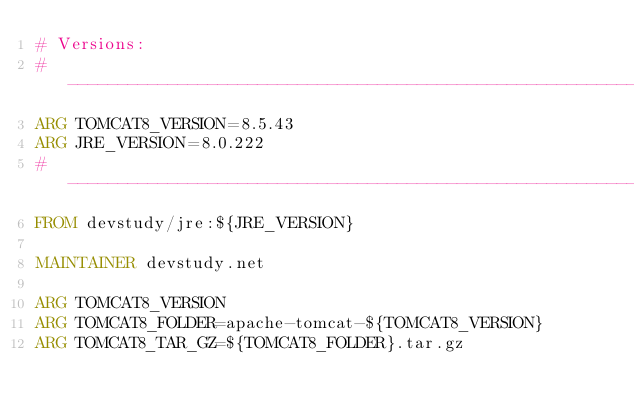Convert code to text. <code><loc_0><loc_0><loc_500><loc_500><_Dockerfile_># Versions:
# ----------------------------------------------------------------------------------------------------------------
ARG TOMCAT8_VERSION=8.5.43
ARG JRE_VERSION=8.0.222
# ----------------------------------------------------------------------------------------------------------------
FROM devstudy/jre:${JRE_VERSION}

MAINTAINER devstudy.net

ARG TOMCAT8_VERSION
ARG TOMCAT8_FOLDER=apache-tomcat-${TOMCAT8_VERSION}
ARG TOMCAT8_TAR_GZ=${TOMCAT8_FOLDER}.tar.gz</code> 